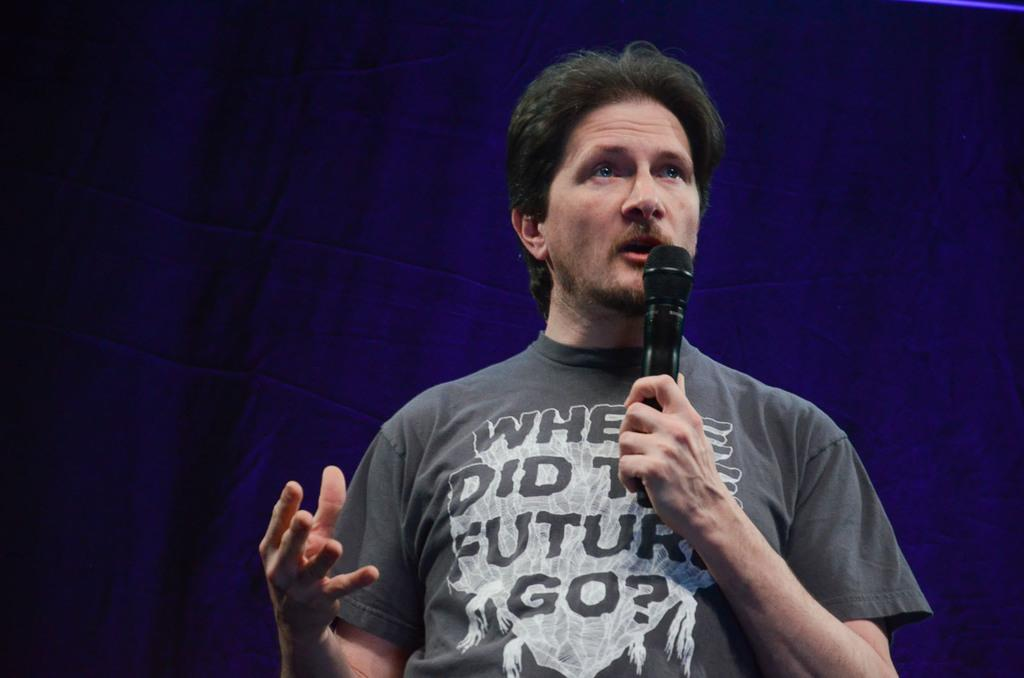Who is present in the image? There is a man in the image. What is the man doing in the image? The man is standing and holding a microphone. What might the man be doing based on his open mouth? The man's open mouth suggests that he is talking. What color cloth can be seen in the background of the image? There is a blue color cloth in the background of the image. What type of bells can be heard ringing in the image? There are no bells present in the image, and therefore no sound can be heard. What type of beef dish is being prepared in the image? There is no beef dish or any food preparation visible in the image. 